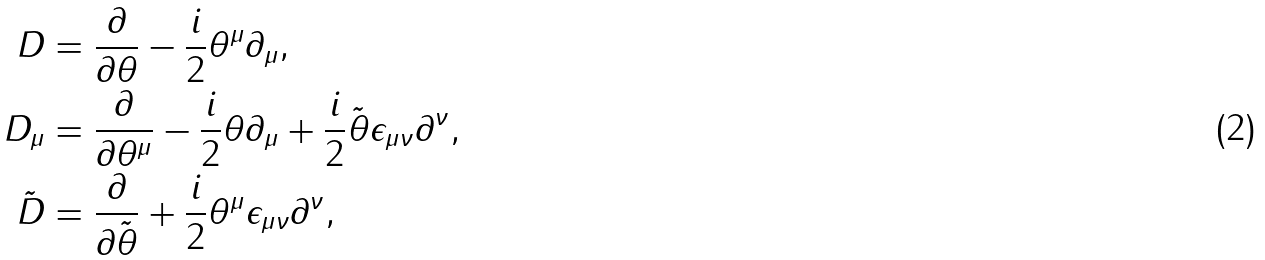Convert formula to latex. <formula><loc_0><loc_0><loc_500><loc_500>D & = \frac { \partial } { \partial \theta } - \frac { i } { 2 } \theta ^ { \mu } \partial _ { \mu } , \\ D _ { \mu } & = \frac { \partial } { \partial \theta ^ { \mu } } - \frac { i } { 2 } \theta \partial _ { \mu } + \frac { i } { 2 } \tilde { \theta } \epsilon _ { \mu \nu } \partial ^ { \nu } , \\ \tilde { D } & = \frac { \partial } { \partial \tilde { \theta } } + \frac { i } { 2 } \theta ^ { \mu } \epsilon _ { \mu \nu } \partial ^ { \nu } ,</formula> 